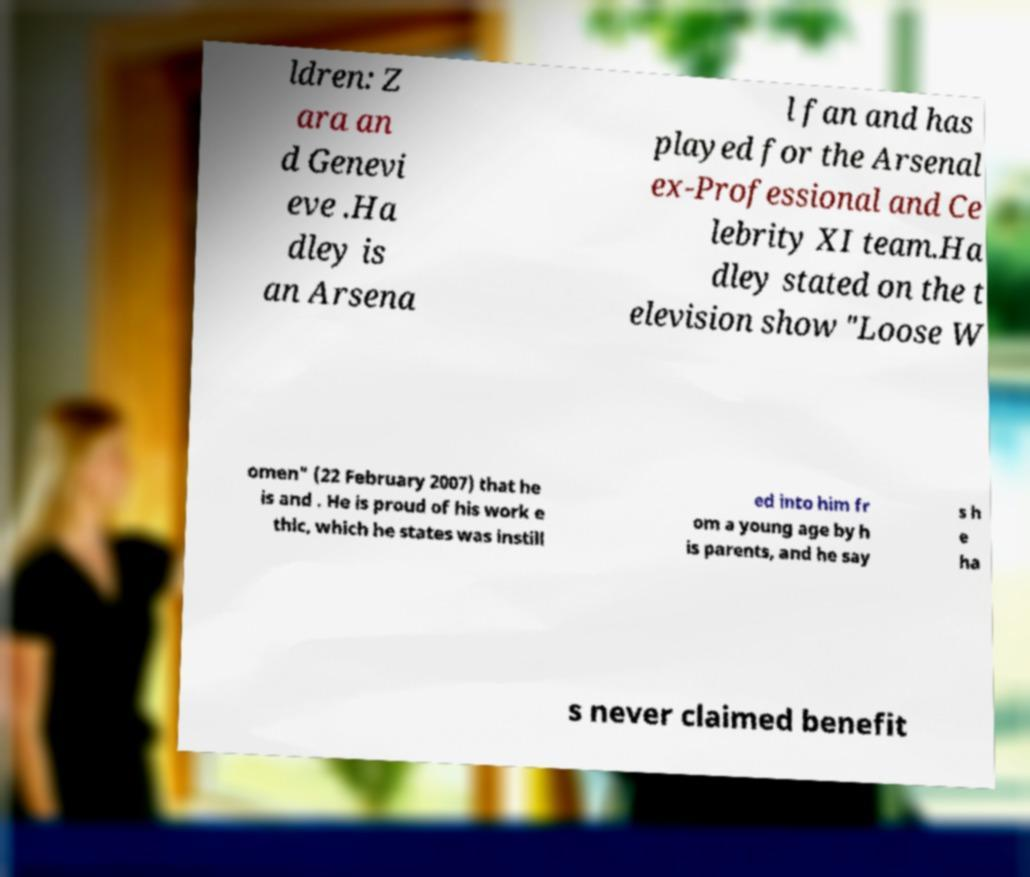Could you extract and type out the text from this image? ldren: Z ara an d Genevi eve .Ha dley is an Arsena l fan and has played for the Arsenal ex-Professional and Ce lebrity XI team.Ha dley stated on the t elevision show "Loose W omen" (22 February 2007) that he is and . He is proud of his work e thic, which he states was instill ed into him fr om a young age by h is parents, and he say s h e ha s never claimed benefit 